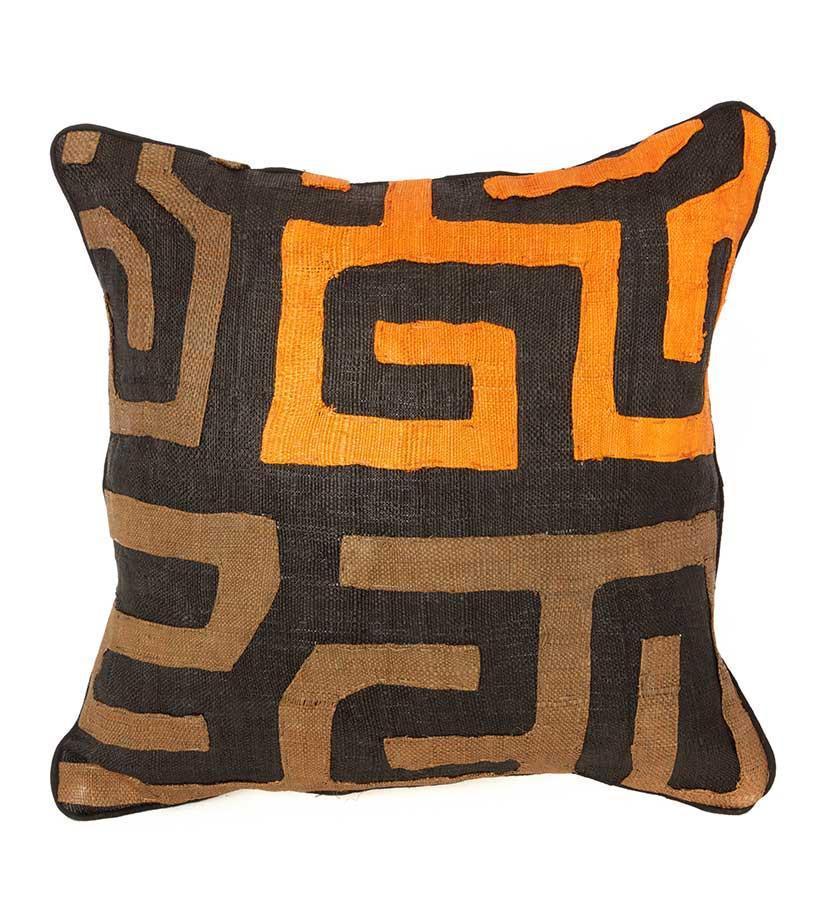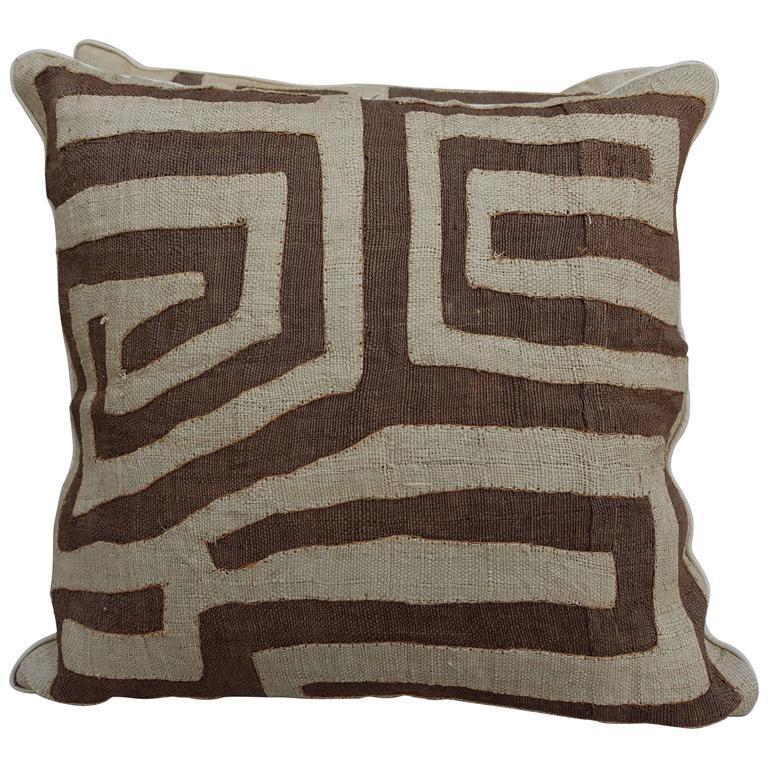The first image is the image on the left, the second image is the image on the right. Analyze the images presented: Is the assertion "All pillows feature a graphic print resembling a maze, and no image contains multiple pillows that don't match." valid? Answer yes or no. Yes. The first image is the image on the left, the second image is the image on the right. Analyze the images presented: Is the assertion "There are three pillows in the two images." valid? Answer yes or no. No. 